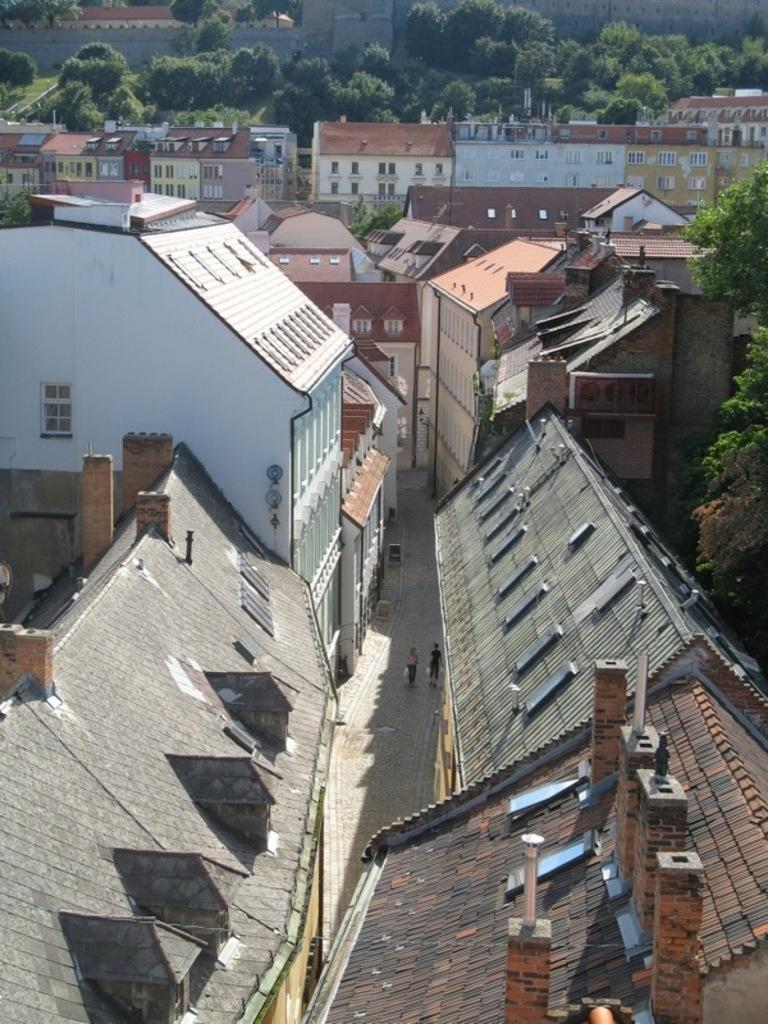What type of structures can be seen in the image? There are buildings in the image. What are the two persons in the image doing? The two persons in the image are walking. What can be seen in the background of the image? There are trees in the background of the image. What is the color of the trees in the image? The trees in the image are green in color. How many eggs are visible in the image? There are no eggs present in the image. What type of division is taking place in the image? There is no division taking place in the image; it features buildings, two persons walking, and trees in the background. 